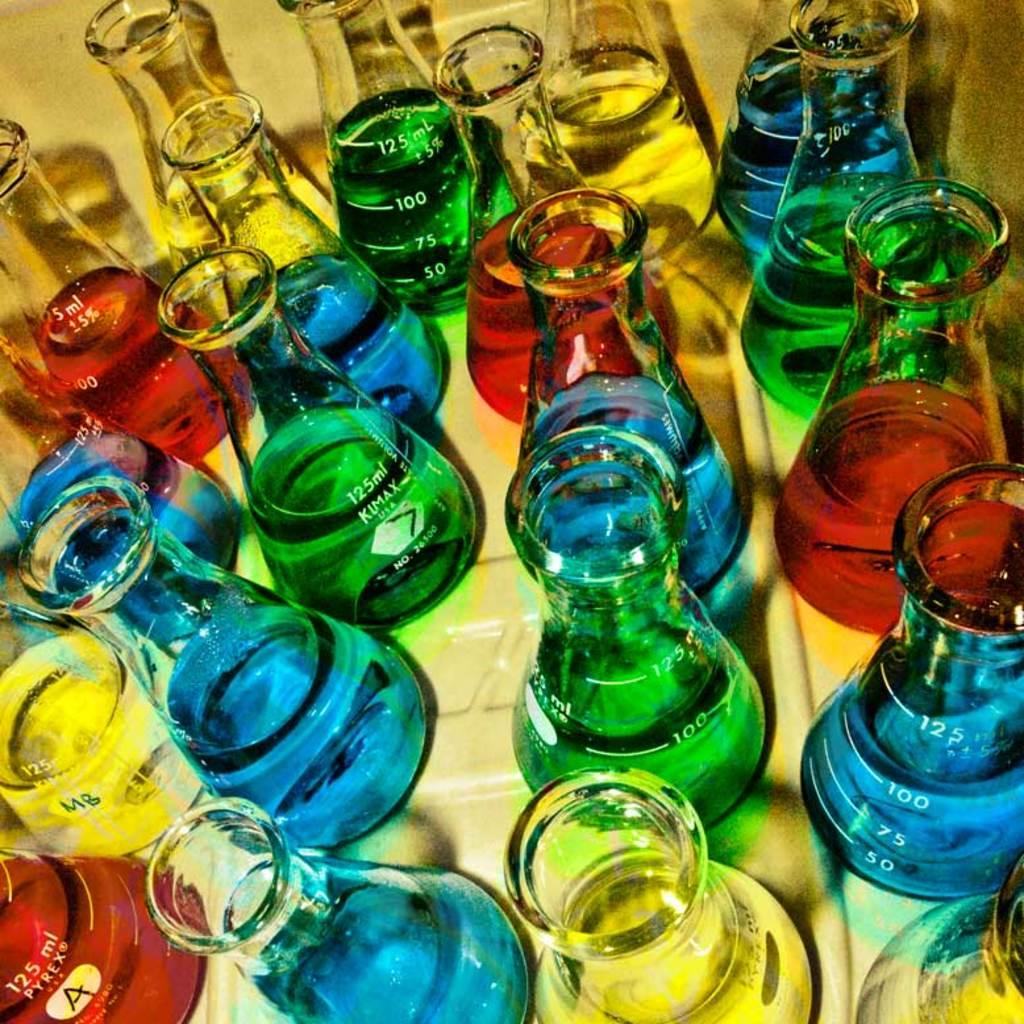<image>
Summarize the visual content of the image. A 125 ml brand kumax beaker with red, green, blue and yellow liquid in it. 